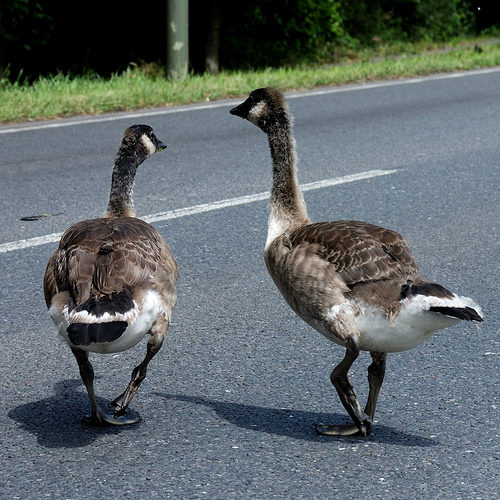<image>
Can you confirm if the ducks is on the road? Yes. Looking at the image, I can see the ducks is positioned on top of the road, with the road providing support. 